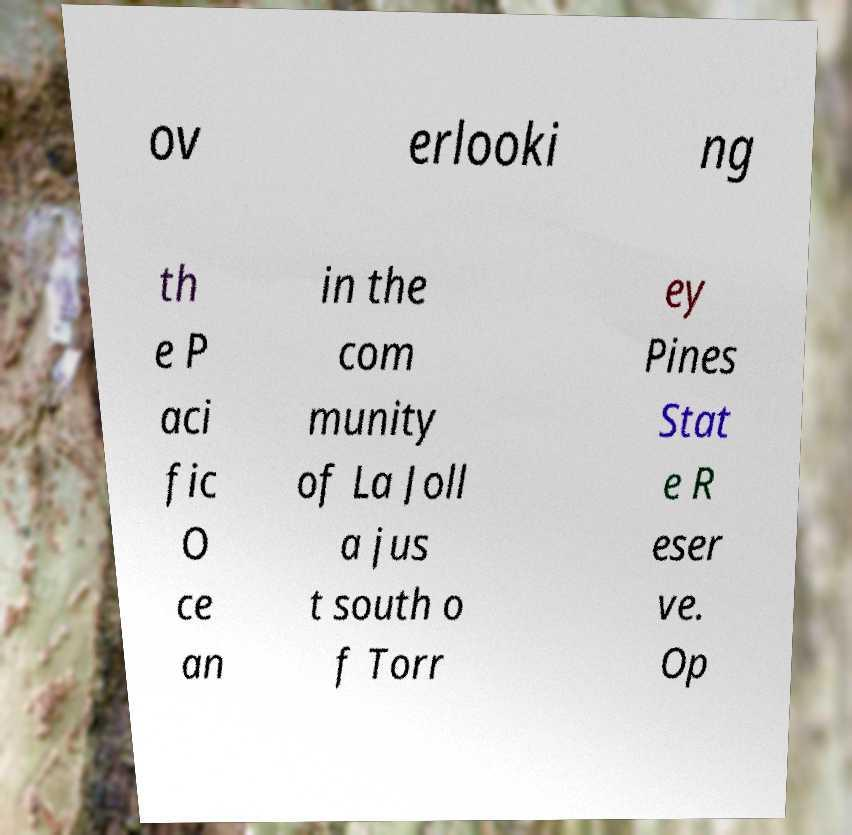I need the written content from this picture converted into text. Can you do that? ov erlooki ng th e P aci fic O ce an in the com munity of La Joll a jus t south o f Torr ey Pines Stat e R eser ve. Op 